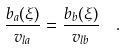Convert formula to latex. <formula><loc_0><loc_0><loc_500><loc_500>\frac { b _ { a } ( \xi ) } { v _ { l a } } = \frac { b _ { b } ( \xi ) } { v _ { l b } } \ \ .</formula> 